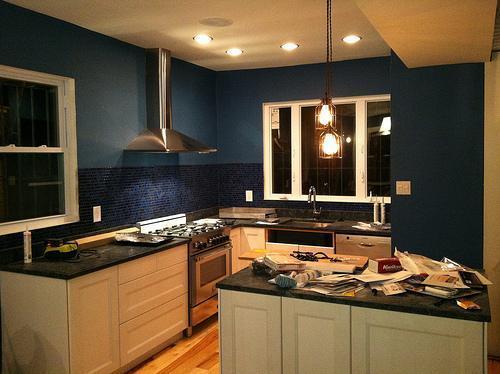How many pendant lights are shown?
Give a very brief answer. 2. 